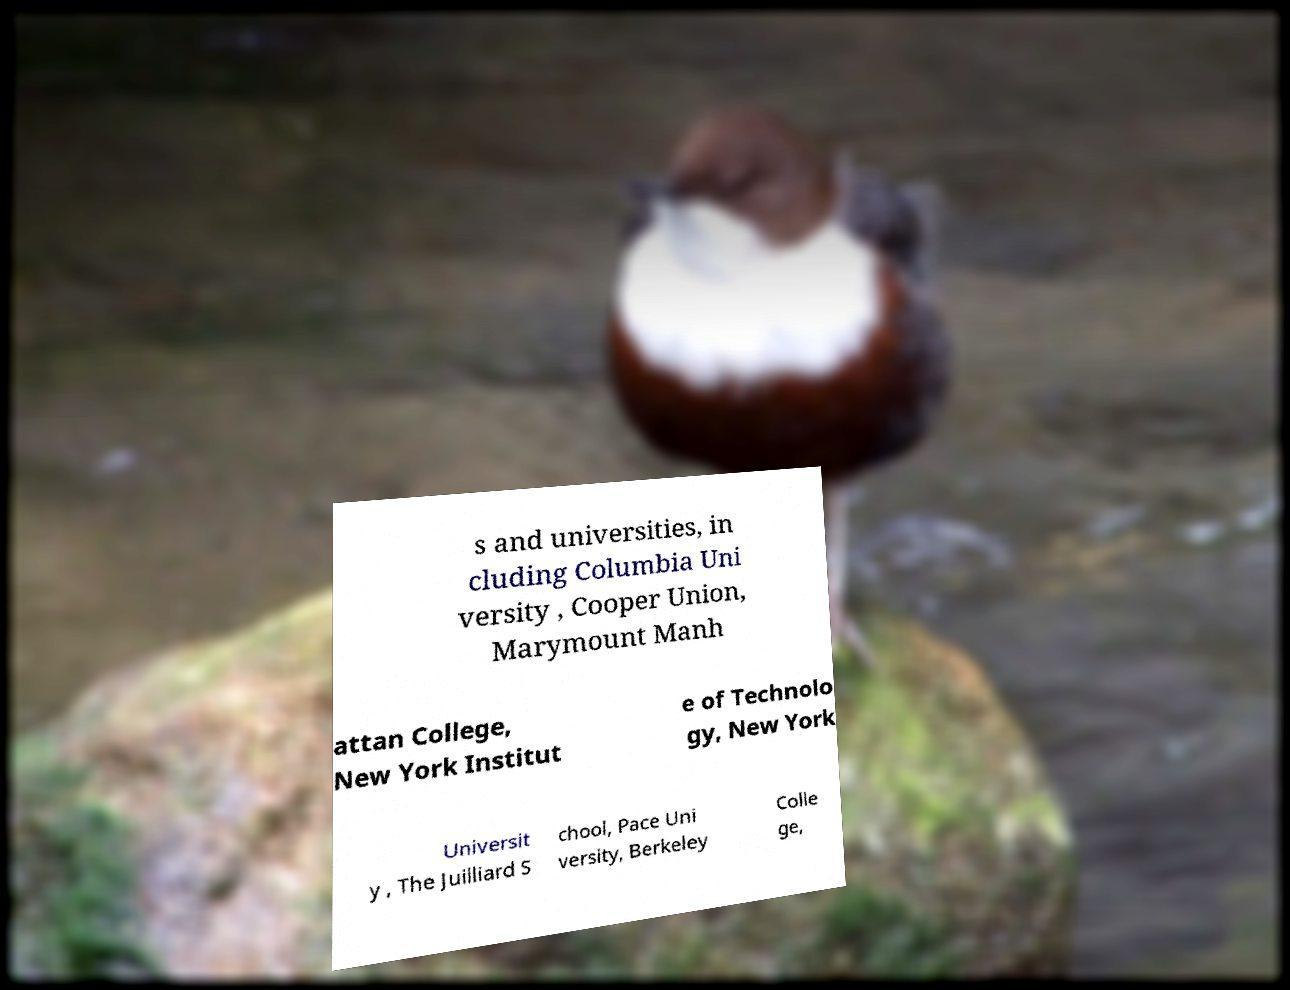Could you assist in decoding the text presented in this image and type it out clearly? s and universities, in cluding Columbia Uni versity , Cooper Union, Marymount Manh attan College, New York Institut e of Technolo gy, New York Universit y , The Juilliard S chool, Pace Uni versity, Berkeley Colle ge, 